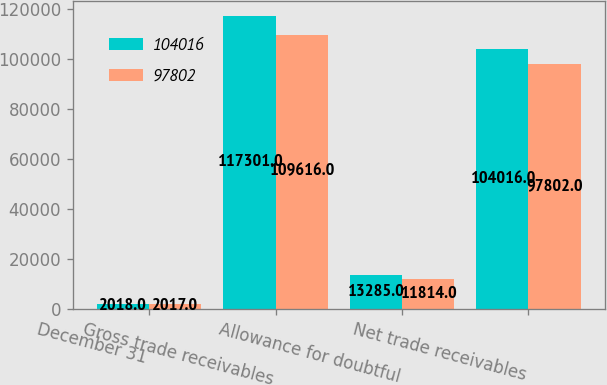<chart> <loc_0><loc_0><loc_500><loc_500><stacked_bar_chart><ecel><fcel>December 31<fcel>Gross trade receivables<fcel>Allowance for doubtful<fcel>Net trade receivables<nl><fcel>104016<fcel>2018<fcel>117301<fcel>13285<fcel>104016<nl><fcel>97802<fcel>2017<fcel>109616<fcel>11814<fcel>97802<nl></chart> 